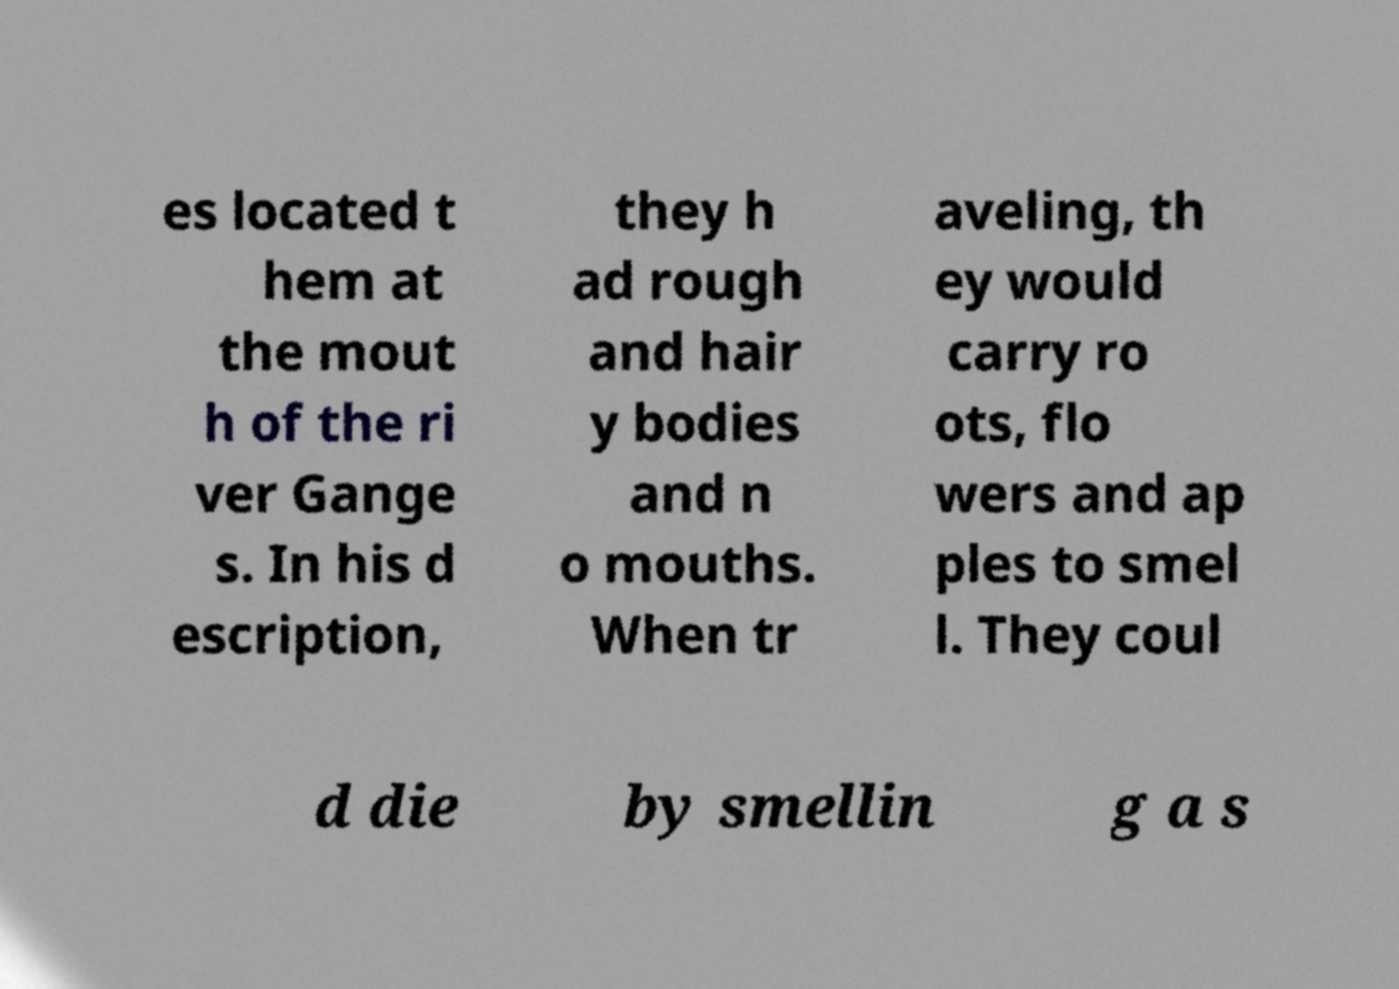Can you read and provide the text displayed in the image?This photo seems to have some interesting text. Can you extract and type it out for me? es located t hem at the mout h of the ri ver Gange s. In his d escription, they h ad rough and hair y bodies and n o mouths. When tr aveling, th ey would carry ro ots, flo wers and ap ples to smel l. They coul d die by smellin g a s 